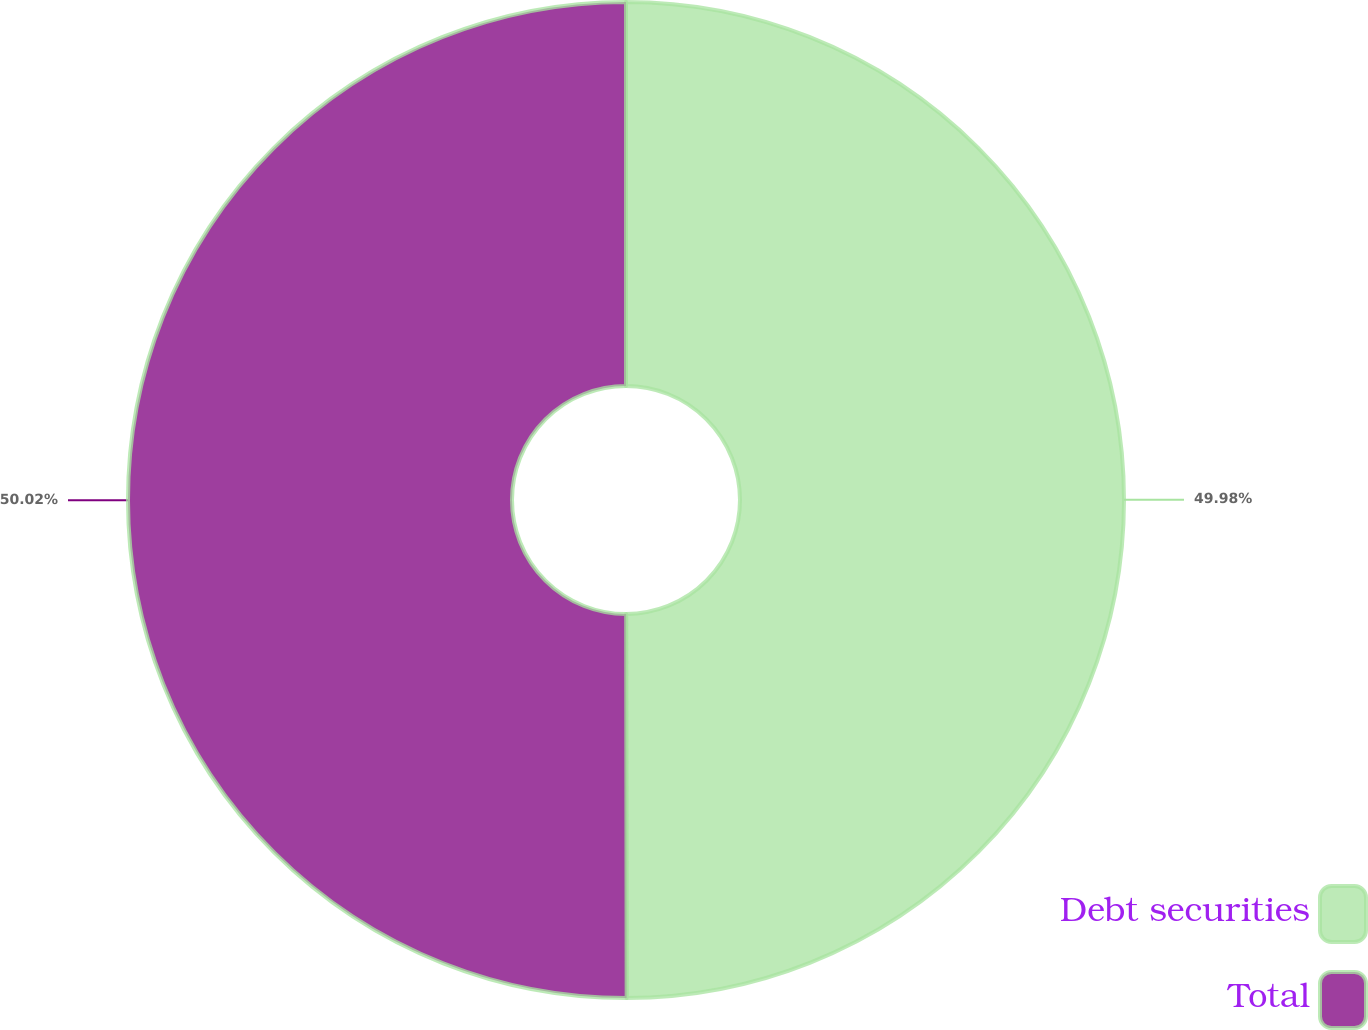<chart> <loc_0><loc_0><loc_500><loc_500><pie_chart><fcel>Debt securities<fcel>Total<nl><fcel>49.98%<fcel>50.02%<nl></chart> 